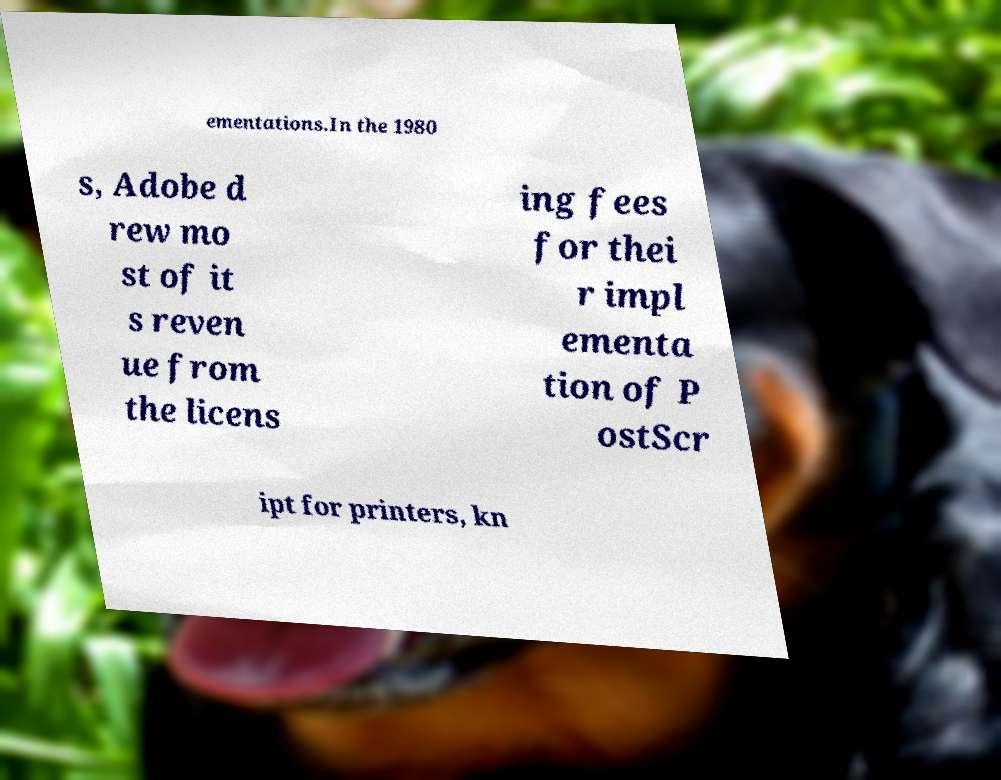For documentation purposes, I need the text within this image transcribed. Could you provide that? ementations.In the 1980 s, Adobe d rew mo st of it s reven ue from the licens ing fees for thei r impl ementa tion of P ostScr ipt for printers, kn 